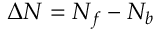Convert formula to latex. <formula><loc_0><loc_0><loc_500><loc_500>\Delta N = N _ { f } - N _ { b }</formula> 